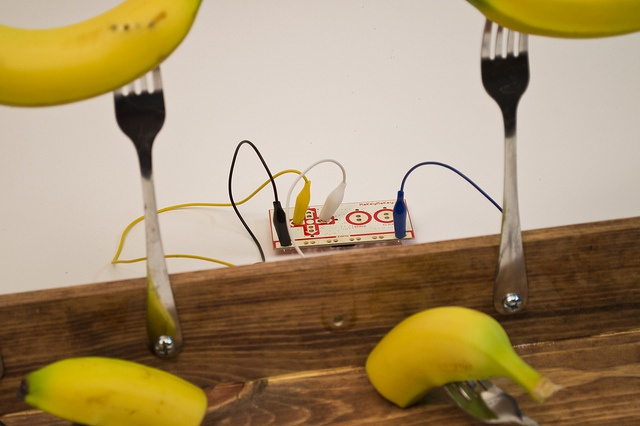Describe the objects in this image and their specific colors. I can see banana in tan, gold, and olive tones, banana in tan, gold, olive, and maroon tones, banana in tan, gold, and olive tones, fork in tan, black, and olive tones, and fork in tan, black, darkgray, maroon, and gray tones in this image. 